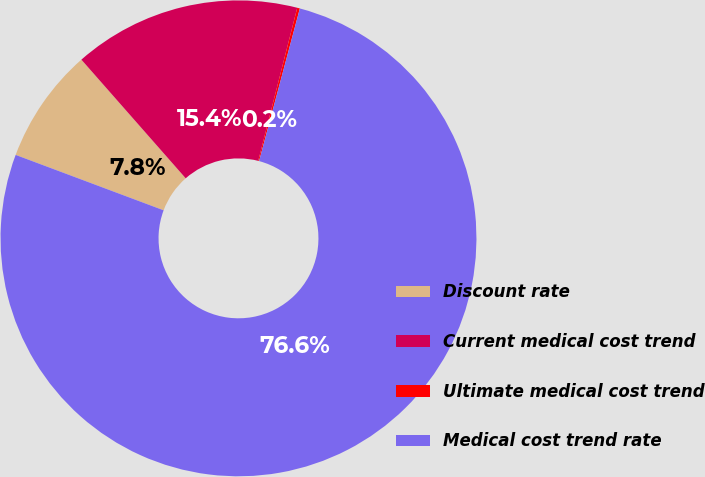Convert chart. <chart><loc_0><loc_0><loc_500><loc_500><pie_chart><fcel>Discount rate<fcel>Current medical cost trend<fcel>Ultimate medical cost trend<fcel>Medical cost trend rate<nl><fcel>7.82%<fcel>15.45%<fcel>0.18%<fcel>76.55%<nl></chart> 